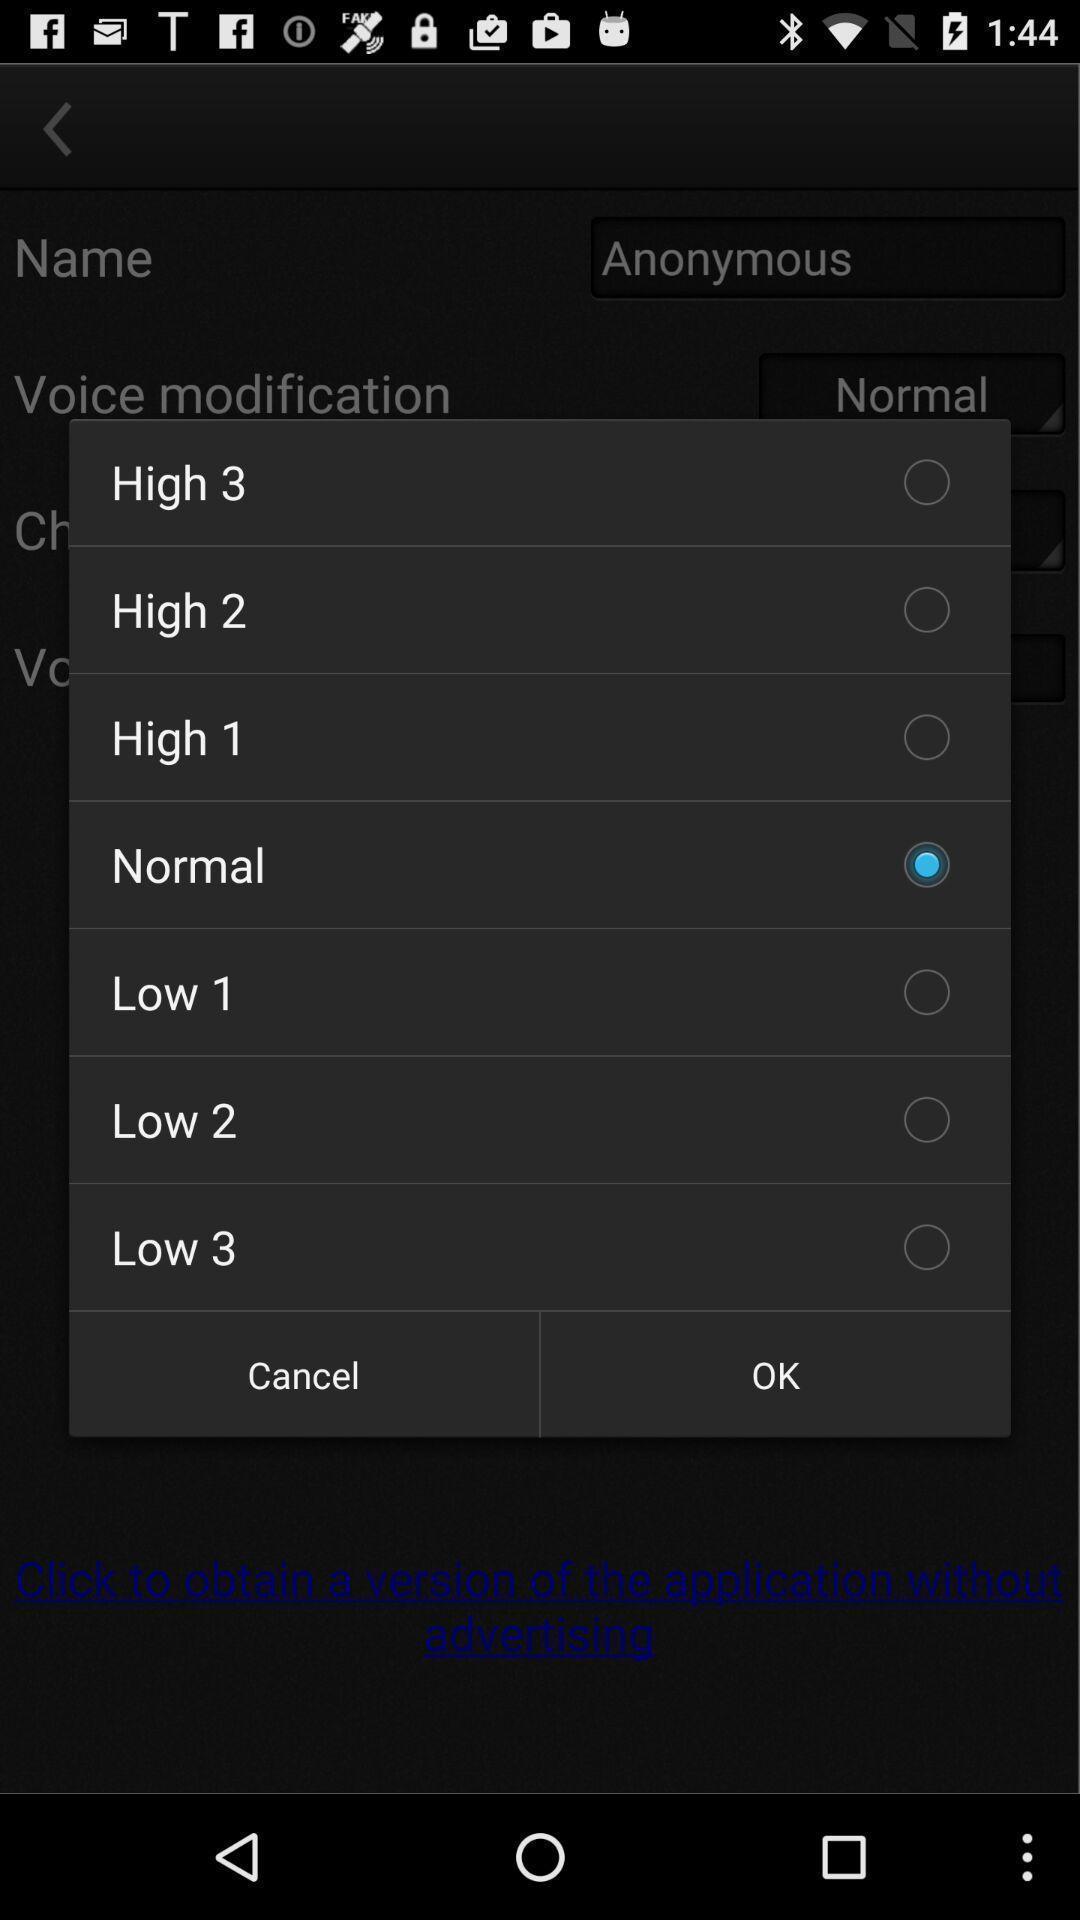Describe the content in this image. Pop-up with selection options in an audio tuning app. 